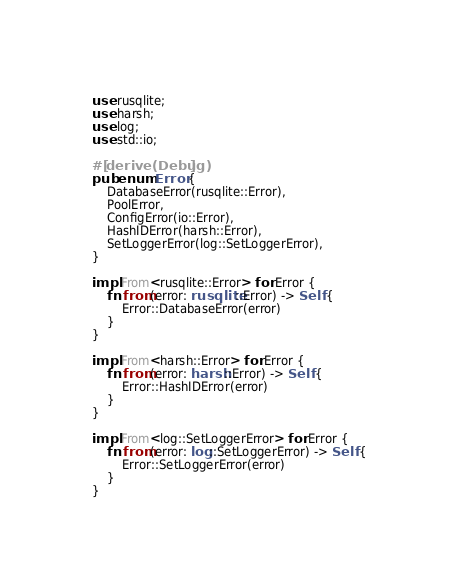Convert code to text. <code><loc_0><loc_0><loc_500><loc_500><_Rust_>use rusqlite;
use harsh;
use log;
use std::io;

#[derive(Debug)]
pub enum Error {
    DatabaseError(rusqlite::Error),
    PoolError,
    ConfigError(io::Error),
    HashIDError(harsh::Error),
    SetLoggerError(log::SetLoggerError),
}

impl From<rusqlite::Error> for Error {
    fn from(error: rusqlite::Error) -> Self {
        Error::DatabaseError(error)
    }
}

impl From<harsh::Error> for Error {
    fn from(error: harsh::Error) -> Self {
        Error::HashIDError(error)
    }
}

impl From<log::SetLoggerError> for Error {
    fn from(error: log::SetLoggerError) -> Self {
        Error::SetLoggerError(error)
    }
}
</code> 